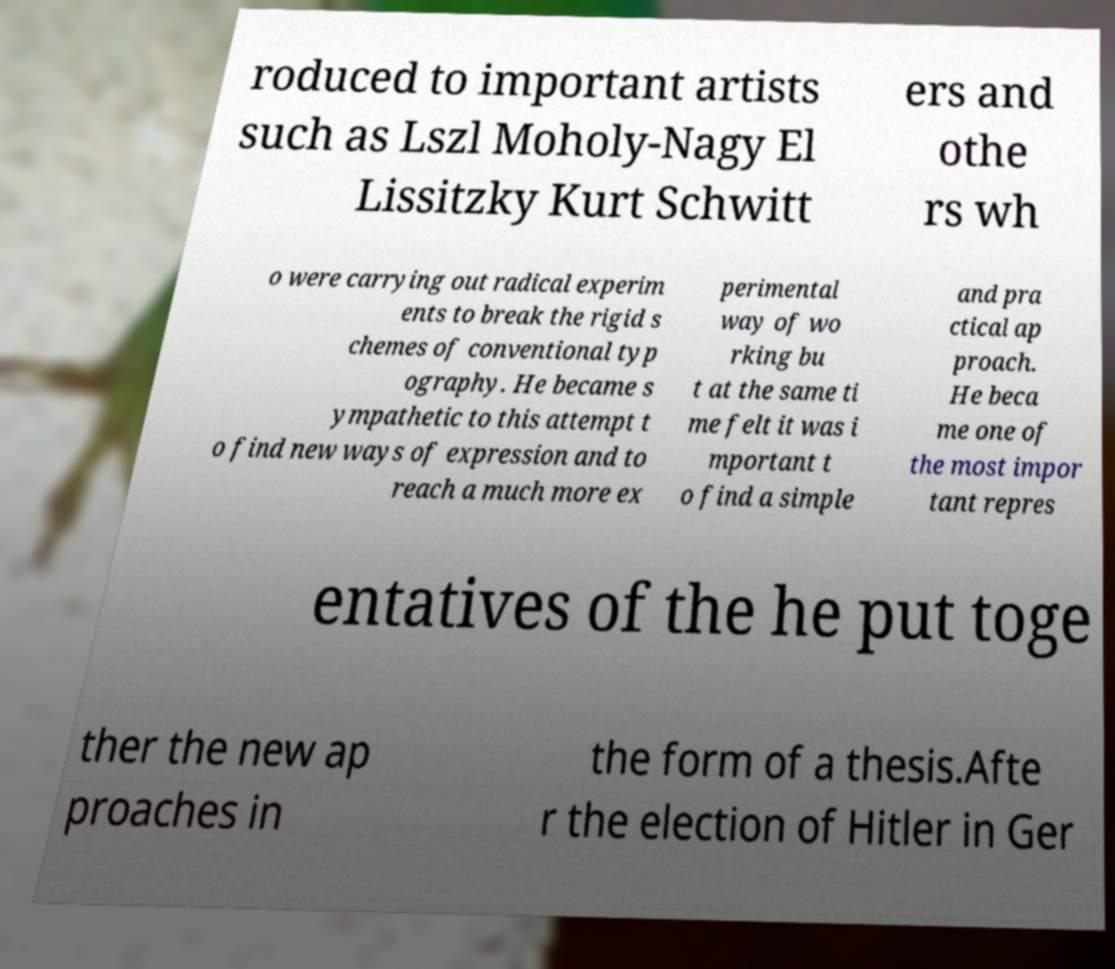I need the written content from this picture converted into text. Can you do that? roduced to important artists such as Lszl Moholy-Nagy El Lissitzky Kurt Schwitt ers and othe rs wh o were carrying out radical experim ents to break the rigid s chemes of conventional typ ography. He became s ympathetic to this attempt t o find new ways of expression and to reach a much more ex perimental way of wo rking bu t at the same ti me felt it was i mportant t o find a simple and pra ctical ap proach. He beca me one of the most impor tant repres entatives of the he put toge ther the new ap proaches in the form of a thesis.Afte r the election of Hitler in Ger 